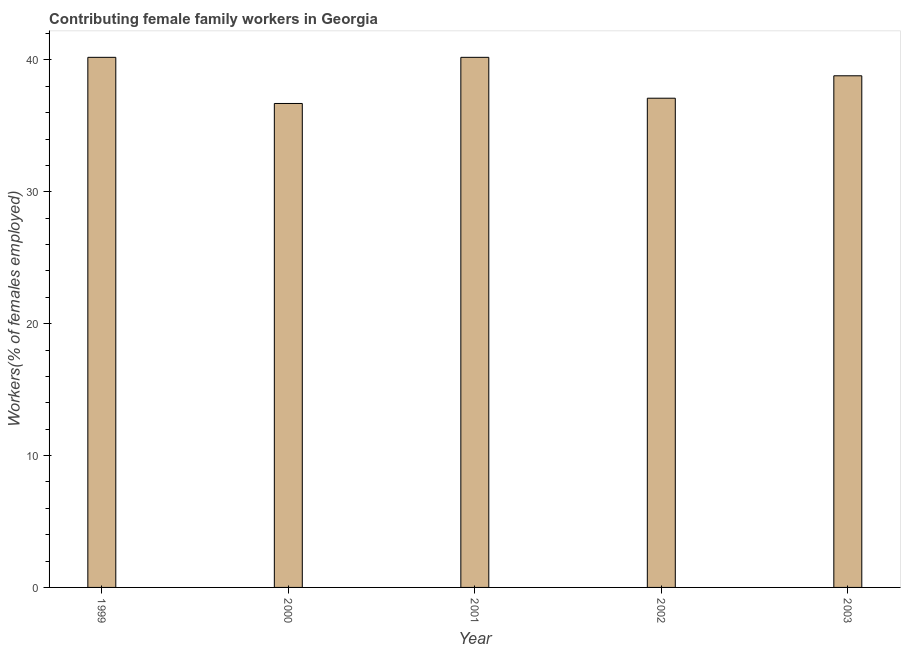Does the graph contain any zero values?
Make the answer very short. No. What is the title of the graph?
Provide a succinct answer. Contributing female family workers in Georgia. What is the label or title of the X-axis?
Provide a short and direct response. Year. What is the label or title of the Y-axis?
Give a very brief answer. Workers(% of females employed). What is the contributing female family workers in 2000?
Offer a very short reply. 36.7. Across all years, what is the maximum contributing female family workers?
Provide a short and direct response. 40.2. Across all years, what is the minimum contributing female family workers?
Your response must be concise. 36.7. In which year was the contributing female family workers maximum?
Offer a terse response. 1999. In which year was the contributing female family workers minimum?
Provide a short and direct response. 2000. What is the sum of the contributing female family workers?
Keep it short and to the point. 193. What is the average contributing female family workers per year?
Keep it short and to the point. 38.6. What is the median contributing female family workers?
Your answer should be very brief. 38.8. In how many years, is the contributing female family workers greater than 12 %?
Your answer should be very brief. 5. What is the difference between the highest and the second highest contributing female family workers?
Your response must be concise. 0. Is the sum of the contributing female family workers in 2001 and 2002 greater than the maximum contributing female family workers across all years?
Ensure brevity in your answer.  Yes. What is the difference between the highest and the lowest contributing female family workers?
Provide a short and direct response. 3.5. What is the difference between two consecutive major ticks on the Y-axis?
Ensure brevity in your answer.  10. Are the values on the major ticks of Y-axis written in scientific E-notation?
Make the answer very short. No. What is the Workers(% of females employed) of 1999?
Offer a very short reply. 40.2. What is the Workers(% of females employed) in 2000?
Ensure brevity in your answer.  36.7. What is the Workers(% of females employed) of 2001?
Your answer should be very brief. 40.2. What is the Workers(% of females employed) of 2002?
Offer a terse response. 37.1. What is the Workers(% of females employed) in 2003?
Ensure brevity in your answer.  38.8. What is the difference between the Workers(% of females employed) in 1999 and 2000?
Offer a very short reply. 3.5. What is the difference between the Workers(% of females employed) in 1999 and 2002?
Your response must be concise. 3.1. What is the difference between the Workers(% of females employed) in 1999 and 2003?
Offer a very short reply. 1.4. What is the difference between the Workers(% of females employed) in 2000 and 2002?
Your answer should be compact. -0.4. What is the difference between the Workers(% of females employed) in 2000 and 2003?
Offer a terse response. -2.1. What is the difference between the Workers(% of females employed) in 2001 and 2002?
Offer a terse response. 3.1. What is the difference between the Workers(% of females employed) in 2001 and 2003?
Your response must be concise. 1.4. What is the ratio of the Workers(% of females employed) in 1999 to that in 2000?
Provide a short and direct response. 1.09. What is the ratio of the Workers(% of females employed) in 1999 to that in 2002?
Your response must be concise. 1.08. What is the ratio of the Workers(% of females employed) in 1999 to that in 2003?
Make the answer very short. 1.04. What is the ratio of the Workers(% of females employed) in 2000 to that in 2001?
Your answer should be compact. 0.91. What is the ratio of the Workers(% of females employed) in 2000 to that in 2002?
Ensure brevity in your answer.  0.99. What is the ratio of the Workers(% of females employed) in 2000 to that in 2003?
Make the answer very short. 0.95. What is the ratio of the Workers(% of females employed) in 2001 to that in 2002?
Offer a terse response. 1.08. What is the ratio of the Workers(% of females employed) in 2001 to that in 2003?
Your answer should be very brief. 1.04. What is the ratio of the Workers(% of females employed) in 2002 to that in 2003?
Give a very brief answer. 0.96. 